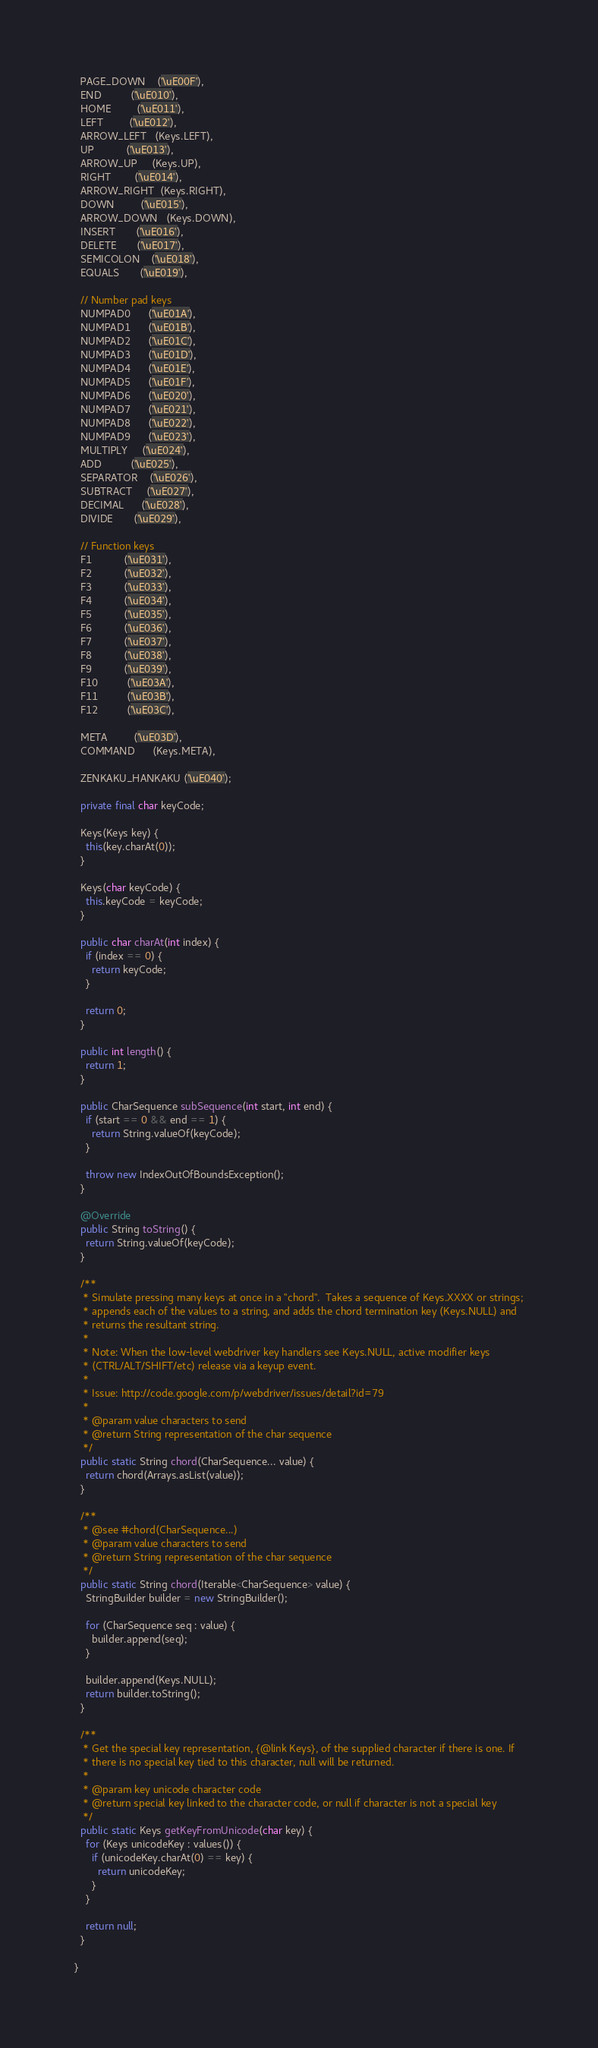Convert code to text. <code><loc_0><loc_0><loc_500><loc_500><_Java_>  PAGE_DOWN    ('\uE00F'),
  END          ('\uE010'),
  HOME         ('\uE011'),
  LEFT         ('\uE012'),
  ARROW_LEFT   (Keys.LEFT),
  UP           ('\uE013'),
  ARROW_UP     (Keys.UP),
  RIGHT        ('\uE014'),
  ARROW_RIGHT  (Keys.RIGHT),
  DOWN         ('\uE015'),
  ARROW_DOWN   (Keys.DOWN),
  INSERT       ('\uE016'),
  DELETE       ('\uE017'),
  SEMICOLON    ('\uE018'),
  EQUALS       ('\uE019'),

  // Number pad keys
  NUMPAD0      ('\uE01A'),
  NUMPAD1      ('\uE01B'),
  NUMPAD2      ('\uE01C'),
  NUMPAD3      ('\uE01D'),
  NUMPAD4      ('\uE01E'),
  NUMPAD5      ('\uE01F'),
  NUMPAD6      ('\uE020'),
  NUMPAD7      ('\uE021'),
  NUMPAD8      ('\uE022'),
  NUMPAD9      ('\uE023'),
  MULTIPLY     ('\uE024'),
  ADD          ('\uE025'),
  SEPARATOR    ('\uE026'),
  SUBTRACT     ('\uE027'),
  DECIMAL      ('\uE028'),
  DIVIDE       ('\uE029'),

  // Function keys
  F1           ('\uE031'),
  F2           ('\uE032'),
  F3           ('\uE033'),
  F4           ('\uE034'),
  F5           ('\uE035'),
  F6           ('\uE036'),
  F7           ('\uE037'),
  F8           ('\uE038'),
  F9           ('\uE039'),
  F10          ('\uE03A'),
  F11          ('\uE03B'),
  F12          ('\uE03C'),

  META         ('\uE03D'),
  COMMAND      (Keys.META),

  ZENKAKU_HANKAKU ('\uE040');

  private final char keyCode;

  Keys(Keys key) {
    this(key.charAt(0));
  }

  Keys(char keyCode) {
    this.keyCode = keyCode;
  }

  public char charAt(int index) {
    if (index == 0) {
      return keyCode;
    }

    return 0;
  }

  public int length() {
    return 1;
  }

  public CharSequence subSequence(int start, int end) {
    if (start == 0 && end == 1) {
      return String.valueOf(keyCode);
    }

    throw new IndexOutOfBoundsException();
  }

  @Override
  public String toString() {
    return String.valueOf(keyCode);
  }

  /**
   * Simulate pressing many keys at once in a "chord".  Takes a sequence of Keys.XXXX or strings;
   * appends each of the values to a string, and adds the chord termination key (Keys.NULL) and
   * returns the resultant string.
   *
   * Note: When the low-level webdriver key handlers see Keys.NULL, active modifier keys
   * (CTRL/ALT/SHIFT/etc) release via a keyup event.
   *
   * Issue: http://code.google.com/p/webdriver/issues/detail?id=79
   *
   * @param value characters to send
   * @return String representation of the char sequence
   */
  public static String chord(CharSequence... value) {
    return chord(Arrays.asList(value));
  }

  /**
   * @see #chord(CharSequence...)
   * @param value characters to send
   * @return String representation of the char sequence
   */
  public static String chord(Iterable<CharSequence> value) {
    StringBuilder builder = new StringBuilder();

    for (CharSequence seq : value) {
      builder.append(seq);
    }

    builder.append(Keys.NULL);
    return builder.toString();
  }

  /**
   * Get the special key representation, {@link Keys}, of the supplied character if there is one. If
   * there is no special key tied to this character, null will be returned.
   *
   * @param key unicode character code
   * @return special key linked to the character code, or null if character is not a special key
   */
  public static Keys getKeyFromUnicode(char key) {
    for (Keys unicodeKey : values()) {
      if (unicodeKey.charAt(0) == key) {
        return unicodeKey;
      }
    }

    return null;
  }

}
</code> 